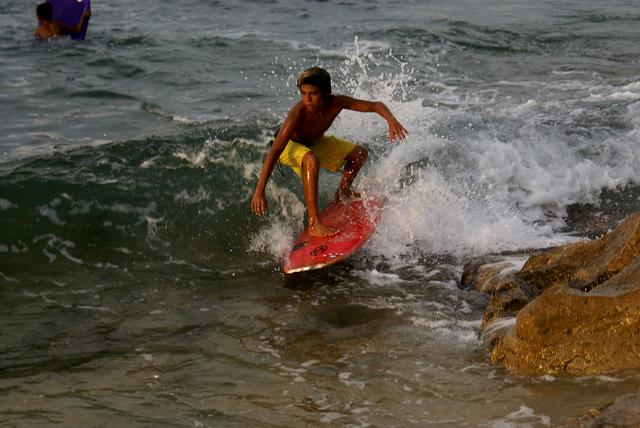What color is the sand on the beach?
Concise answer only. Brown. What color are the boy's trunks?
Write a very short answer. Yellow. What color are the surfer's shorts?
Keep it brief. Yellow. What color is the water?
Give a very brief answer. Green. Is the water placid?
Give a very brief answer. No. How old is the surfer, old or young?
Write a very short answer. Young. 